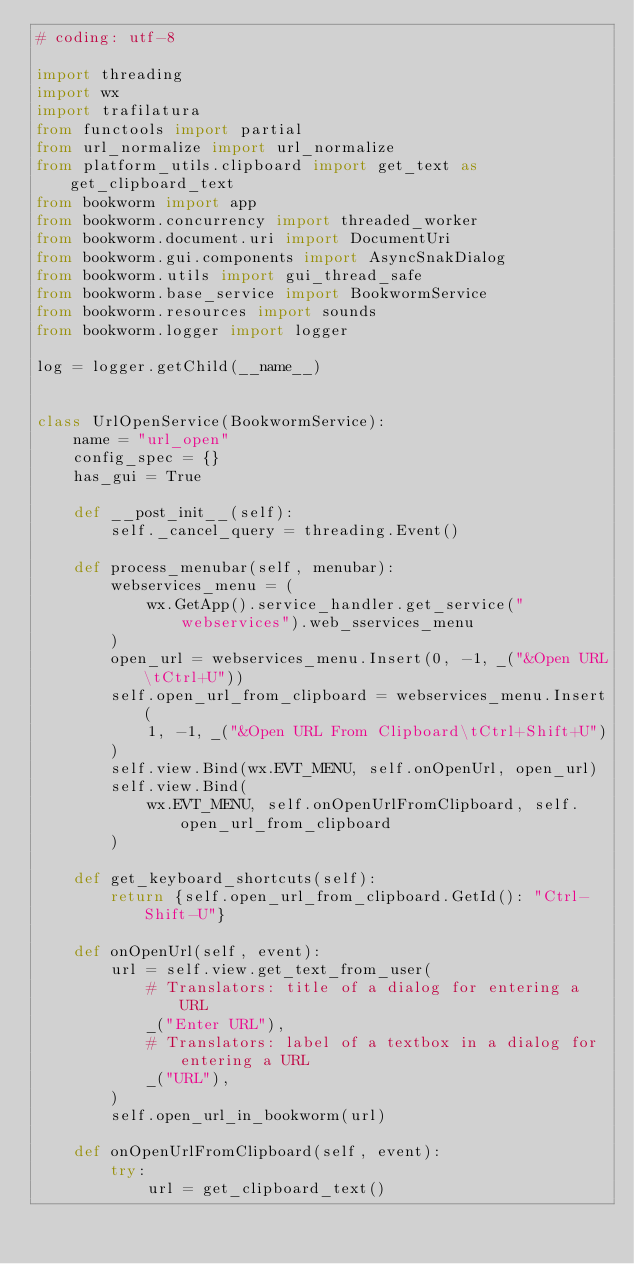<code> <loc_0><loc_0><loc_500><loc_500><_Python_># coding: utf-8

import threading
import wx
import trafilatura
from functools import partial
from url_normalize import url_normalize
from platform_utils.clipboard import get_text as get_clipboard_text
from bookworm import app
from bookworm.concurrency import threaded_worker
from bookworm.document.uri import DocumentUri
from bookworm.gui.components import AsyncSnakDialog
from bookworm.utils import gui_thread_safe
from bookworm.base_service import BookwormService
from bookworm.resources import sounds
from bookworm.logger import logger

log = logger.getChild(__name__)


class UrlOpenService(BookwormService):
    name = "url_open"
    config_spec = {}
    has_gui = True

    def __post_init__(self):
        self._cancel_query = threading.Event()

    def process_menubar(self, menubar):
        webservices_menu = (
            wx.GetApp().service_handler.get_service("webservices").web_sservices_menu
        )
        open_url = webservices_menu.Insert(0, -1, _("&Open URL\tCtrl+U"))
        self.open_url_from_clipboard = webservices_menu.Insert(
            1, -1, _("&Open URL From Clipboard\tCtrl+Shift+U")
        )
        self.view.Bind(wx.EVT_MENU, self.onOpenUrl, open_url)
        self.view.Bind(
            wx.EVT_MENU, self.onOpenUrlFromClipboard, self.open_url_from_clipboard
        )

    def get_keyboard_shortcuts(self):
        return {self.open_url_from_clipboard.GetId(): "Ctrl-Shift-U"}

    def onOpenUrl(self, event):
        url = self.view.get_text_from_user(
            # Translators: title of a dialog for entering a URL
            _("Enter URL"),
            # Translators: label of a textbox in a dialog for entering a URL
            _("URL"),
        )
        self.open_url_in_bookworm(url)

    def onOpenUrlFromClipboard(self, event):
        try:
            url = get_clipboard_text()</code> 